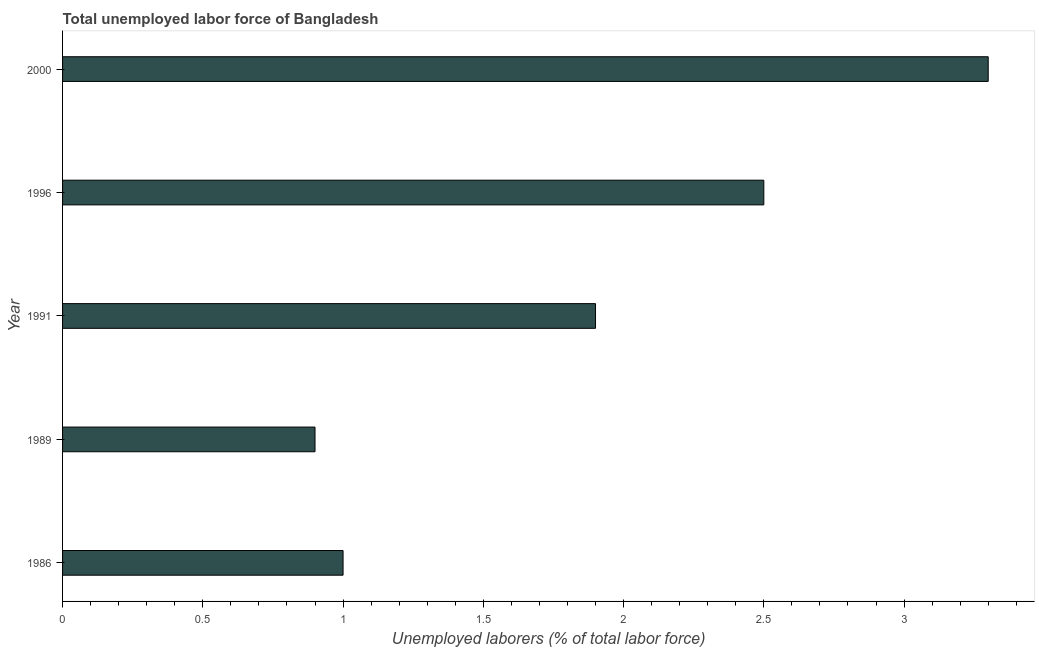Does the graph contain any zero values?
Your answer should be very brief. No. What is the title of the graph?
Make the answer very short. Total unemployed labor force of Bangladesh. What is the label or title of the X-axis?
Offer a very short reply. Unemployed laborers (% of total labor force). What is the label or title of the Y-axis?
Ensure brevity in your answer.  Year. What is the total unemployed labour force in 1996?
Ensure brevity in your answer.  2.5. Across all years, what is the maximum total unemployed labour force?
Ensure brevity in your answer.  3.3. Across all years, what is the minimum total unemployed labour force?
Provide a short and direct response. 0.9. In which year was the total unemployed labour force maximum?
Ensure brevity in your answer.  2000. What is the sum of the total unemployed labour force?
Provide a short and direct response. 9.6. What is the average total unemployed labour force per year?
Offer a very short reply. 1.92. What is the median total unemployed labour force?
Offer a very short reply. 1.9. Do a majority of the years between 1991 and 2000 (inclusive) have total unemployed labour force greater than 1.6 %?
Provide a succinct answer. Yes. What is the ratio of the total unemployed labour force in 1989 to that in 1996?
Keep it short and to the point. 0.36. Is the total unemployed labour force in 1986 less than that in 1991?
Ensure brevity in your answer.  Yes. Is the difference between the total unemployed labour force in 1986 and 1991 greater than the difference between any two years?
Ensure brevity in your answer.  No. What is the difference between the highest and the second highest total unemployed labour force?
Offer a terse response. 0.8. How many bars are there?
Provide a succinct answer. 5. How many years are there in the graph?
Your response must be concise. 5. What is the Unemployed laborers (% of total labor force) of 1989?
Your answer should be very brief. 0.9. What is the Unemployed laborers (% of total labor force) in 1991?
Provide a succinct answer. 1.9. What is the Unemployed laborers (% of total labor force) of 2000?
Your response must be concise. 3.3. What is the difference between the Unemployed laborers (% of total labor force) in 1986 and 1989?
Provide a short and direct response. 0.1. What is the difference between the Unemployed laborers (% of total labor force) in 1986 and 1991?
Provide a short and direct response. -0.9. What is the difference between the Unemployed laborers (% of total labor force) in 1986 and 2000?
Offer a very short reply. -2.3. What is the difference between the Unemployed laborers (% of total labor force) in 1989 and 1991?
Offer a terse response. -1. What is the difference between the Unemployed laborers (% of total labor force) in 1991 and 1996?
Provide a short and direct response. -0.6. What is the difference between the Unemployed laborers (% of total labor force) in 1991 and 2000?
Keep it short and to the point. -1.4. What is the difference between the Unemployed laborers (% of total labor force) in 1996 and 2000?
Provide a short and direct response. -0.8. What is the ratio of the Unemployed laborers (% of total labor force) in 1986 to that in 1989?
Give a very brief answer. 1.11. What is the ratio of the Unemployed laborers (% of total labor force) in 1986 to that in 1991?
Give a very brief answer. 0.53. What is the ratio of the Unemployed laborers (% of total labor force) in 1986 to that in 2000?
Make the answer very short. 0.3. What is the ratio of the Unemployed laborers (% of total labor force) in 1989 to that in 1991?
Ensure brevity in your answer.  0.47. What is the ratio of the Unemployed laborers (% of total labor force) in 1989 to that in 1996?
Offer a terse response. 0.36. What is the ratio of the Unemployed laborers (% of total labor force) in 1989 to that in 2000?
Provide a short and direct response. 0.27. What is the ratio of the Unemployed laborers (% of total labor force) in 1991 to that in 1996?
Your answer should be compact. 0.76. What is the ratio of the Unemployed laborers (% of total labor force) in 1991 to that in 2000?
Offer a very short reply. 0.58. What is the ratio of the Unemployed laborers (% of total labor force) in 1996 to that in 2000?
Provide a succinct answer. 0.76. 